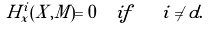Convert formula to latex. <formula><loc_0><loc_0><loc_500><loc_500>H _ { x } ^ { i } ( X , M ) = 0 \ \ i f \quad i \neq d .</formula> 